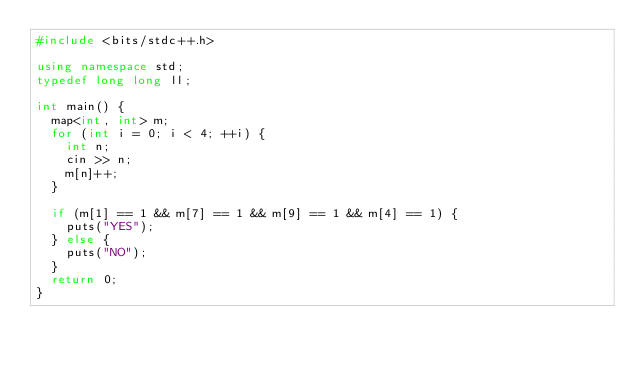Convert code to text. <code><loc_0><loc_0><loc_500><loc_500><_C++_>#include <bits/stdc++.h>

using namespace std;
typedef long long ll;

int main() {
  map<int, int> m;
  for (int i = 0; i < 4; ++i) {
    int n;
    cin >> n;
    m[n]++;
  }

  if (m[1] == 1 && m[7] == 1 && m[9] == 1 && m[4] == 1) {
    puts("YES");
  } else {
    puts("NO");
  }
  return 0;
}


</code> 